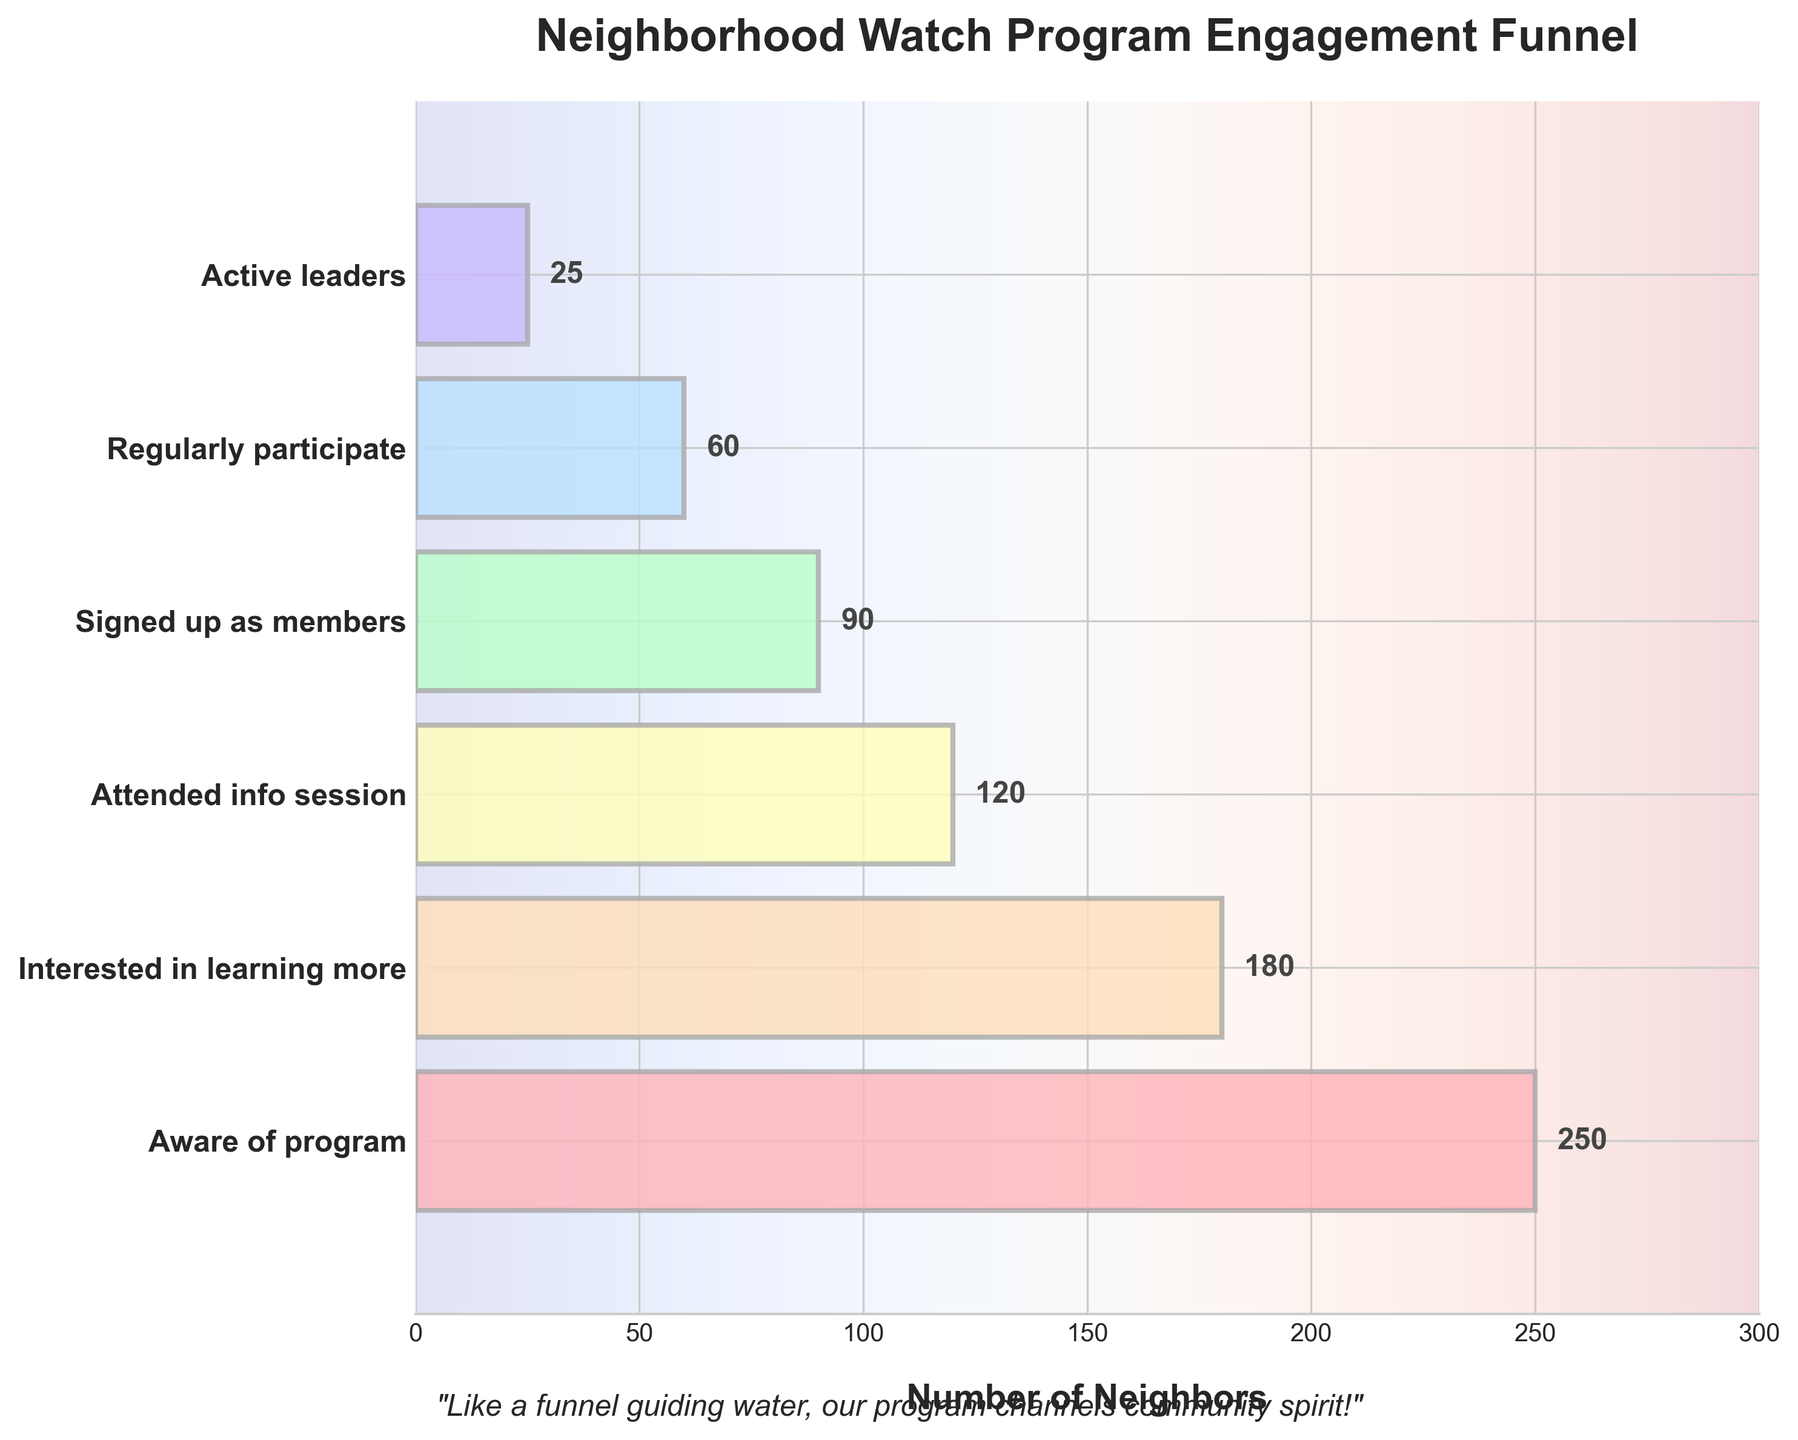What is the title of the figure? The title is written prominently at the top of the figure in bold. It provides an overview of what the chart is about.
Answer: Neighborhood Watch Program Engagement Funnel How many stages are displayed in the funnel chart? The stages are listed along the y-axis, and counting them gives the total number.
Answer: 6 What is the number of neighbors aware of the program? The bar length corresponding to "Aware of program" shows the value, which is also labeled.
Answer: 250 How many more neighbors are interested in learning more compared to those who regularly participate? Subtract the number of neighbors who regularly participate from those interested in learning more: 180 - 60 = 120.
Answer: 120 Which stage has the smallest number of neighbors, and what is that number? Identify the stage with the shortest bar and the lowest labeled value.
Answer: Active leaders, 25 How many total neighbors attended the info session and signed up as members? Add the numbers for "Attended info session" and "Signed up as members": 120 + 90 = 210.
Answer: 210 By how much does the number of neighbors decrease from those who attended the info session to those who signed up as members? Subtract the number of neighbors who signed up as members from those who attended the info session: 120 - 90 = 30.
Answer: 30 What percentage of neighbors who are aware of the program end up becoming active leaders? Divide the number of active leaders by those aware of the program and multiply by 100: (25 / 250) * 100 = 10%.
Answer: 10% What is the difference between the number of neighbors who attended the info session and those who regularly participate? Subtract the number of neighbors who regularly participate from those who attended the info session: 120 - 60 = 60.
Answer: 60 Is the number of neighbors who regularly participate greater than those who signed up as members? Compare the numbers for "Regularly participate" (60) and "Signed up as members" (90).
Answer: No 